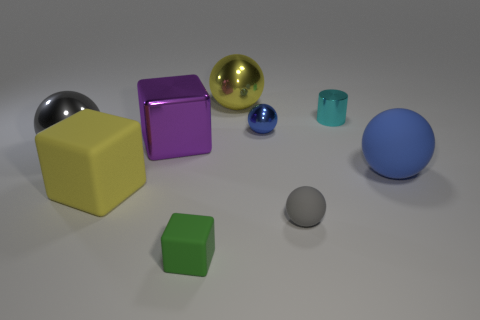Subtract all purple balls. Subtract all purple cylinders. How many balls are left? 5 Subtract all cylinders. How many objects are left? 8 Add 9 cyan metal things. How many cyan metal things are left? 10 Add 6 yellow rubber cubes. How many yellow rubber cubes exist? 7 Subtract 0 cyan cubes. How many objects are left? 9 Subtract all gray metal objects. Subtract all small gray balls. How many objects are left? 7 